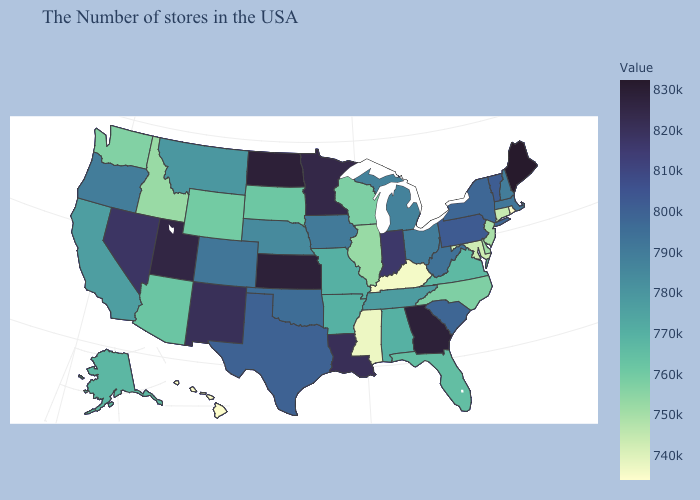Does Illinois have the lowest value in the MidWest?
Write a very short answer. Yes. Does Rhode Island have the lowest value in the USA?
Keep it brief. Yes. Does the map have missing data?
Keep it brief. No. Does the map have missing data?
Answer briefly. No. Among the states that border North Dakota , does Minnesota have the highest value?
Be succinct. Yes. Which states have the highest value in the USA?
Concise answer only. Maine. Does South Carolina have the highest value in the USA?
Keep it brief. No. Does Pennsylvania have a higher value than Louisiana?
Be succinct. No. 